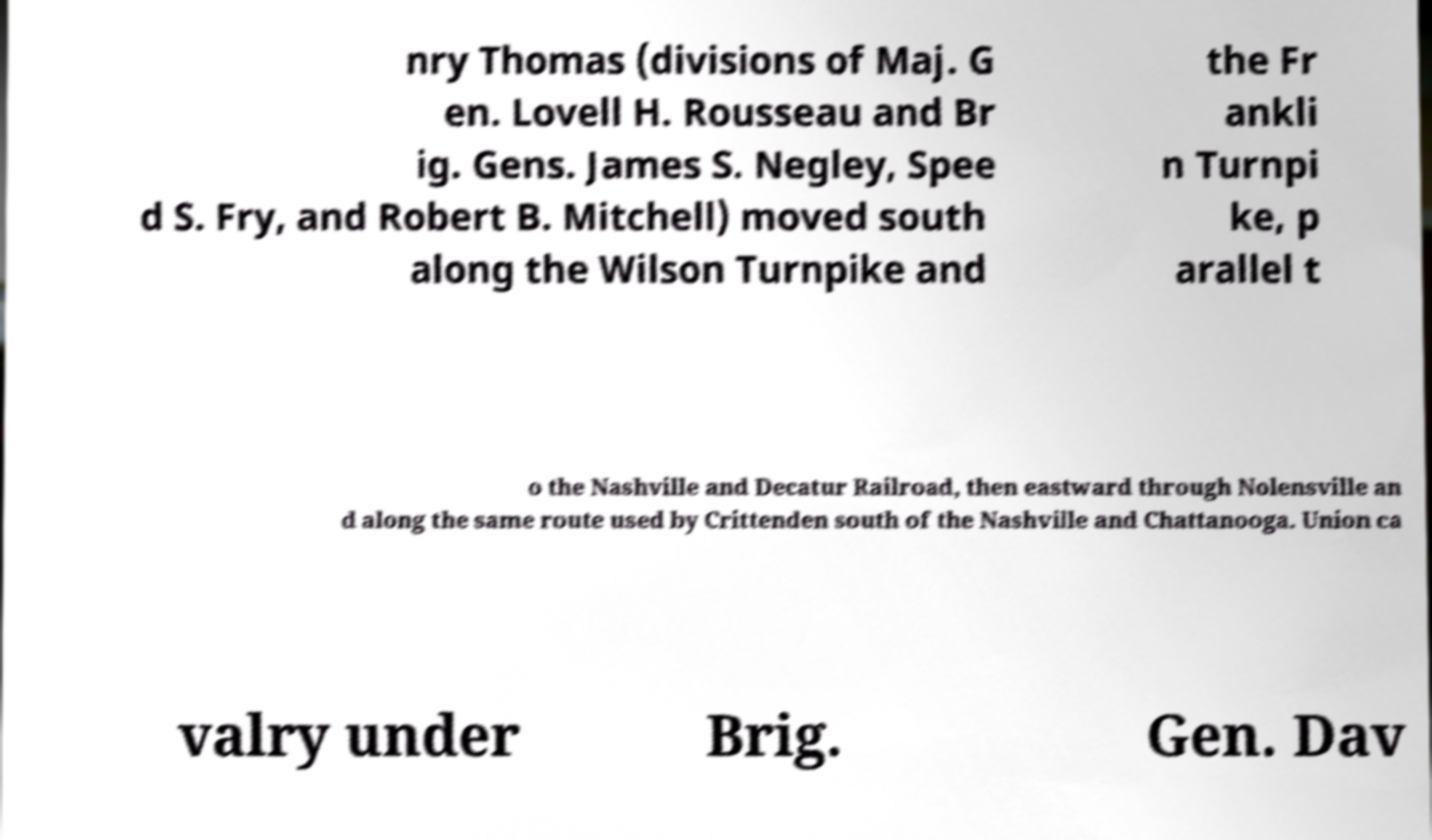Can you read and provide the text displayed in the image?This photo seems to have some interesting text. Can you extract and type it out for me? nry Thomas (divisions of Maj. G en. Lovell H. Rousseau and Br ig. Gens. James S. Negley, Spee d S. Fry, and Robert B. Mitchell) moved south along the Wilson Turnpike and the Fr ankli n Turnpi ke, p arallel t o the Nashville and Decatur Railroad, then eastward through Nolensville an d along the same route used by Crittenden south of the Nashville and Chattanooga. Union ca valry under Brig. Gen. Dav 